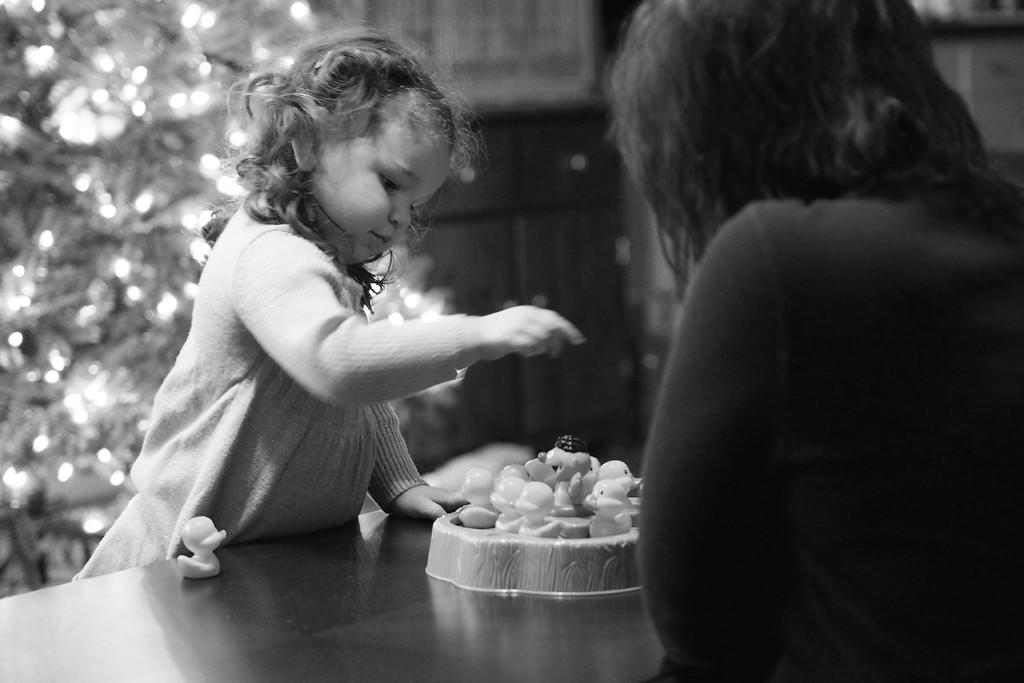Please provide a concise description of this image. This image is a black and white image. This image is taken outdoors. In this image the background is a little blurred. At the bottom of the image there is a table with a few toys on it. On the right side of the image there is a person. In the middle of the image a kid is standing. 